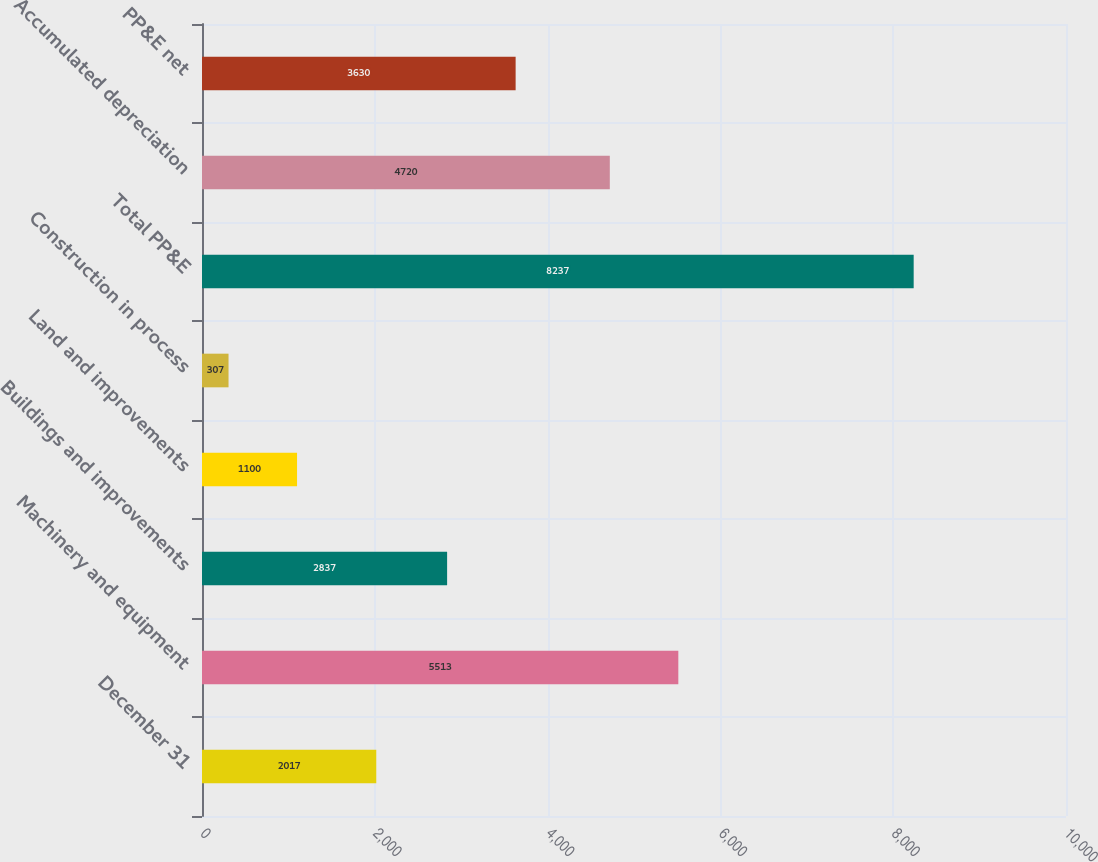<chart> <loc_0><loc_0><loc_500><loc_500><bar_chart><fcel>December 31<fcel>Machinery and equipment<fcel>Buildings and improvements<fcel>Land and improvements<fcel>Construction in process<fcel>Total PP&E<fcel>Accumulated depreciation<fcel>PP&E net<nl><fcel>2017<fcel>5513<fcel>2837<fcel>1100<fcel>307<fcel>8237<fcel>4720<fcel>3630<nl></chart> 